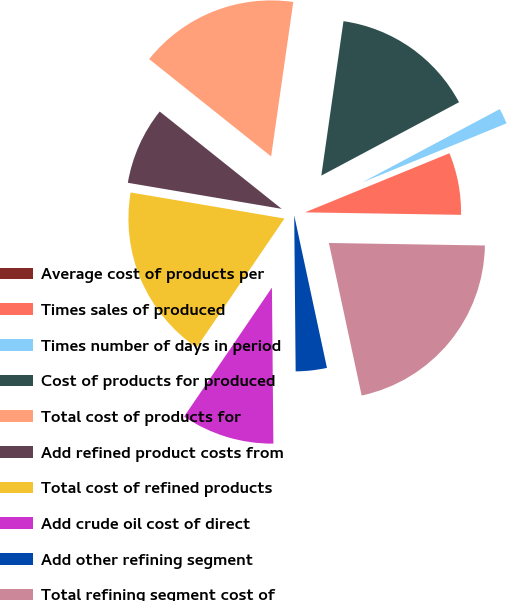Convert chart. <chart><loc_0><loc_0><loc_500><loc_500><pie_chart><fcel>Average cost of products per<fcel>Times sales of produced<fcel>Times number of days in period<fcel>Cost of products for produced<fcel>Total cost of products for<fcel>Add refined product costs from<fcel>Total cost of refined products<fcel>Add crude oil cost of direct<fcel>Add other refining segment<fcel>Total refining segment cost of<nl><fcel>0.0%<fcel>6.44%<fcel>1.61%<fcel>14.94%<fcel>16.55%<fcel>8.05%<fcel>18.16%<fcel>9.66%<fcel>3.22%<fcel>21.38%<nl></chart> 